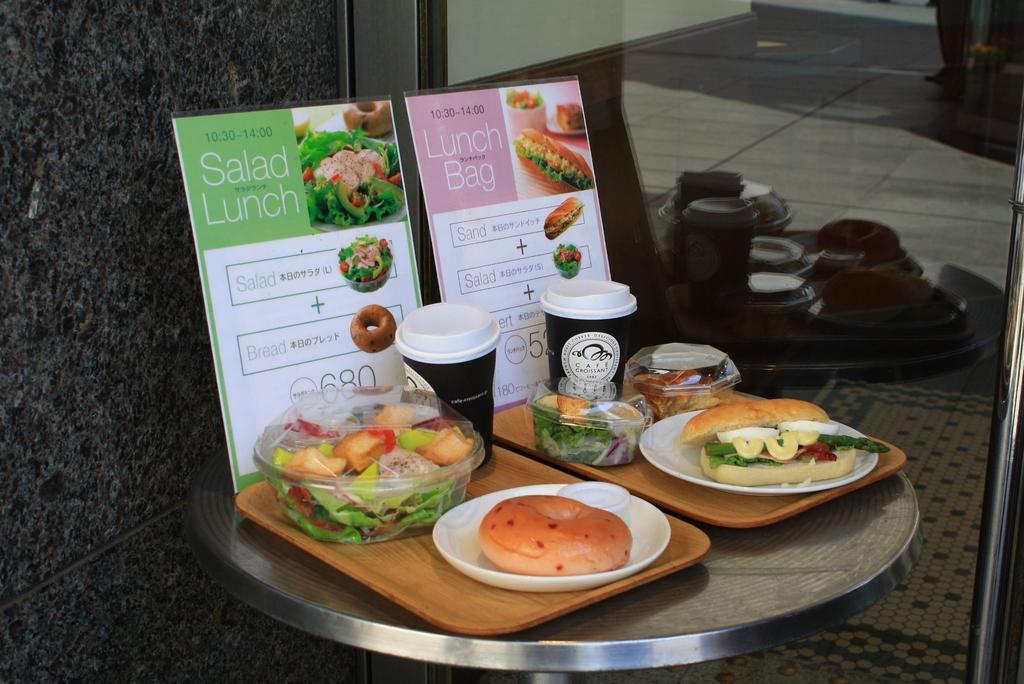How would you summarize this image in a sentence or two? In this image I can see there is a table. On the table there is a plate and a box in that there are some food items. And there are cups and a menu card. And at the back there is a wall. And there is a steel rod. And there is a glass through it, I can see there is a floor. 